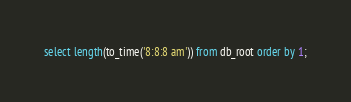<code> <loc_0><loc_0><loc_500><loc_500><_SQL_>select length(to_time('8:8:8 am')) from db_root order by 1;</code> 